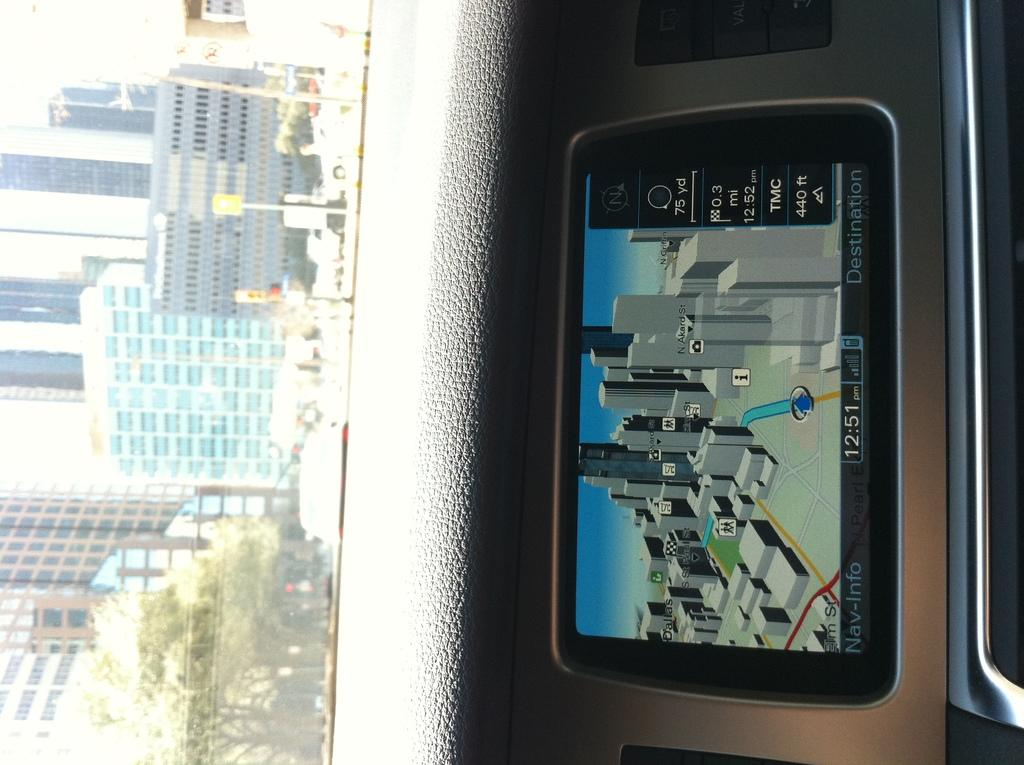<image>
Offer a succinct explanation of the picture presented. A GPS device named Nav Info shows a 3D map of the city. 